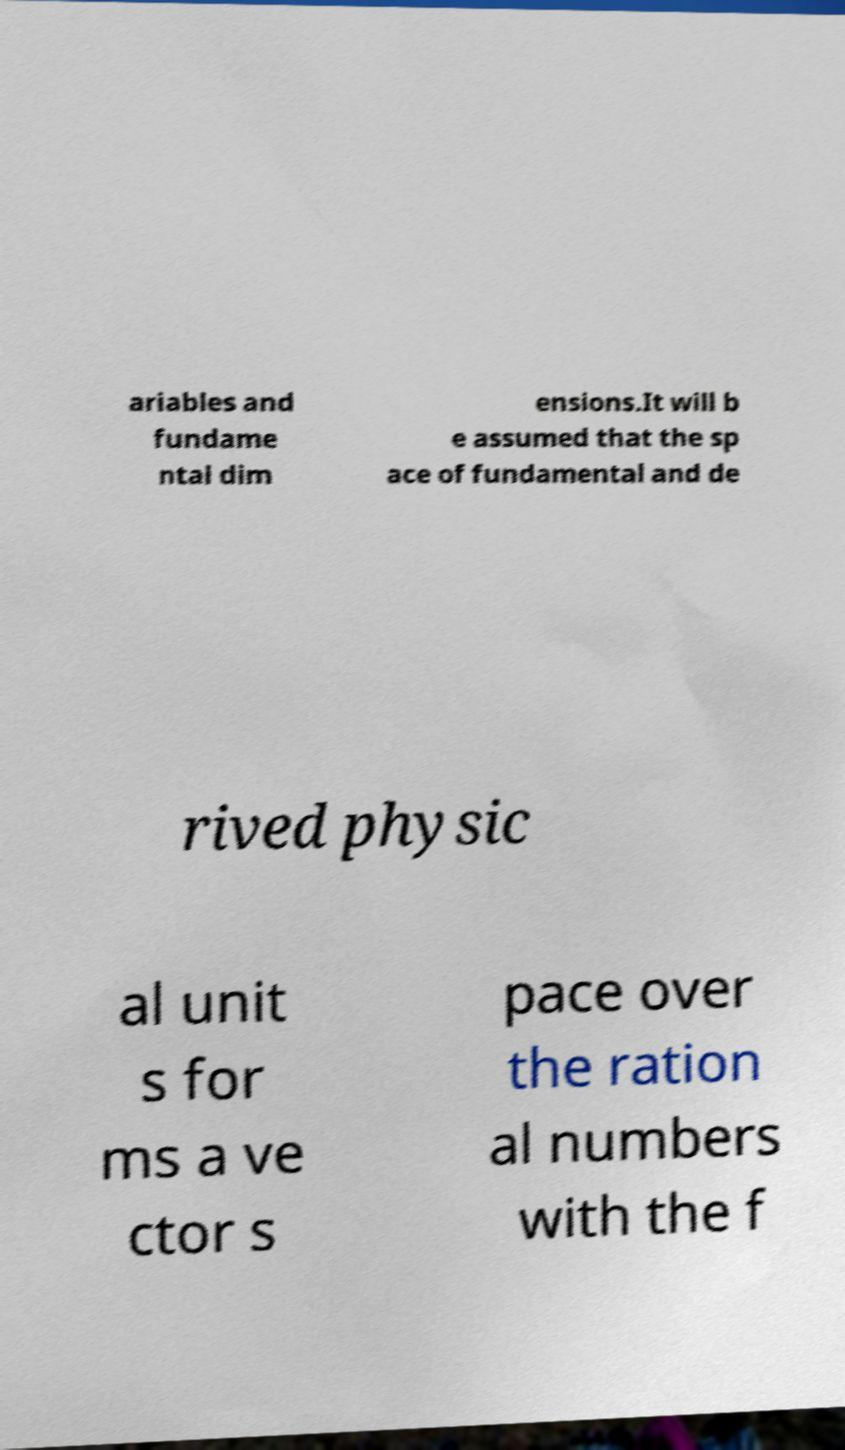Could you extract and type out the text from this image? ariables and fundame ntal dim ensions.It will b e assumed that the sp ace of fundamental and de rived physic al unit s for ms a ve ctor s pace over the ration al numbers with the f 